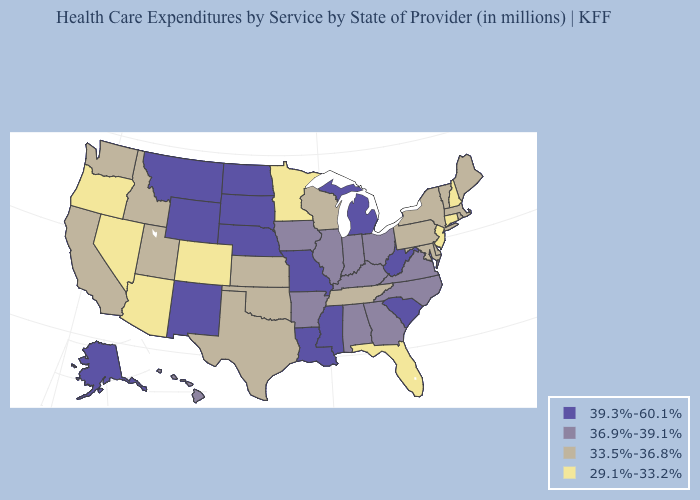What is the lowest value in the Northeast?
Quick response, please. 29.1%-33.2%. Does the map have missing data?
Short answer required. No. What is the value of Florida?
Write a very short answer. 29.1%-33.2%. What is the highest value in the West ?
Write a very short answer. 39.3%-60.1%. Does Maryland have the highest value in the South?
Short answer required. No. Which states have the lowest value in the West?
Quick response, please. Arizona, Colorado, Nevada, Oregon. Name the states that have a value in the range 29.1%-33.2%?
Answer briefly. Arizona, Colorado, Connecticut, Florida, Minnesota, Nevada, New Hampshire, New Jersey, Oregon. What is the value of Wisconsin?
Quick response, please. 33.5%-36.8%. Name the states that have a value in the range 33.5%-36.8%?
Quick response, please. California, Delaware, Idaho, Kansas, Maine, Maryland, Massachusetts, New York, Oklahoma, Pennsylvania, Rhode Island, Tennessee, Texas, Utah, Vermont, Washington, Wisconsin. What is the value of Florida?
Answer briefly. 29.1%-33.2%. Does Michigan have a higher value than Alabama?
Write a very short answer. Yes. What is the value of North Carolina?
Give a very brief answer. 36.9%-39.1%. What is the highest value in the USA?
Answer briefly. 39.3%-60.1%. What is the value of North Dakota?
Write a very short answer. 39.3%-60.1%. Name the states that have a value in the range 39.3%-60.1%?
Keep it brief. Alaska, Louisiana, Michigan, Mississippi, Missouri, Montana, Nebraska, New Mexico, North Dakota, South Carolina, South Dakota, West Virginia, Wyoming. 